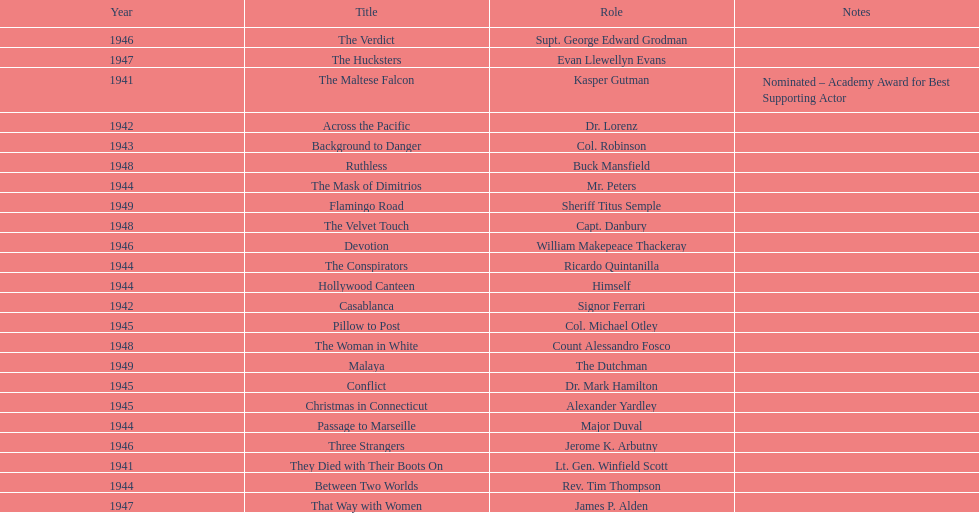Which movie did he get nominated for an oscar for? The Maltese Falcon. 